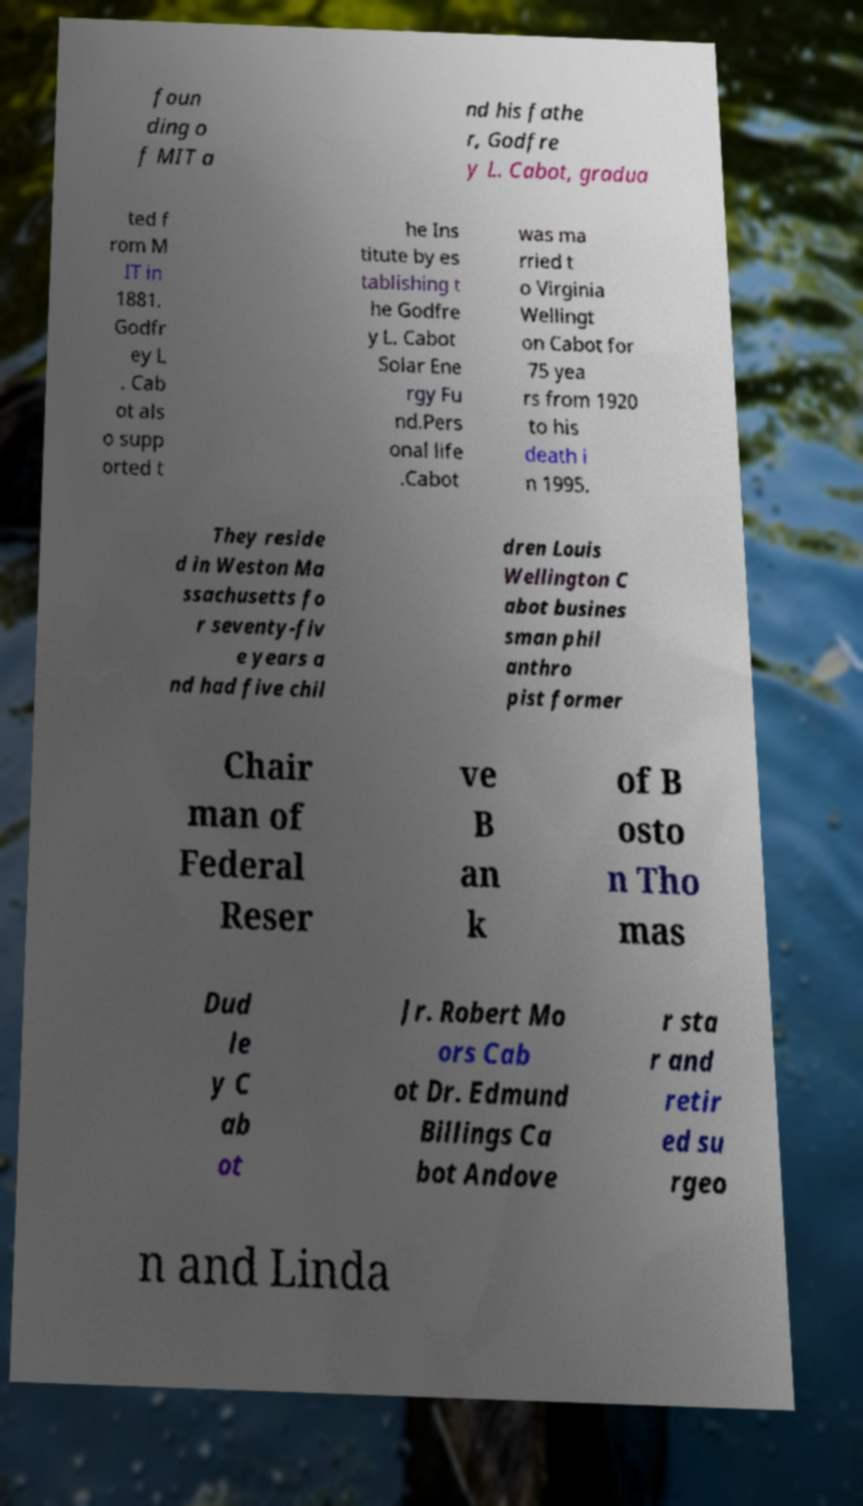Could you extract and type out the text from this image? foun ding o f MIT a nd his fathe r, Godfre y L. Cabot, gradua ted f rom M IT in 1881. Godfr ey L . Cab ot als o supp orted t he Ins titute by es tablishing t he Godfre y L. Cabot Solar Ene rgy Fu nd.Pers onal life .Cabot was ma rried t o Virginia Wellingt on Cabot for 75 yea rs from 1920 to his death i n 1995. They reside d in Weston Ma ssachusetts fo r seventy-fiv e years a nd had five chil dren Louis Wellington C abot busines sman phil anthro pist former Chair man of Federal Reser ve B an k of B osto n Tho mas Dud le y C ab ot Jr. Robert Mo ors Cab ot Dr. Edmund Billings Ca bot Andove r sta r and retir ed su rgeo n and Linda 